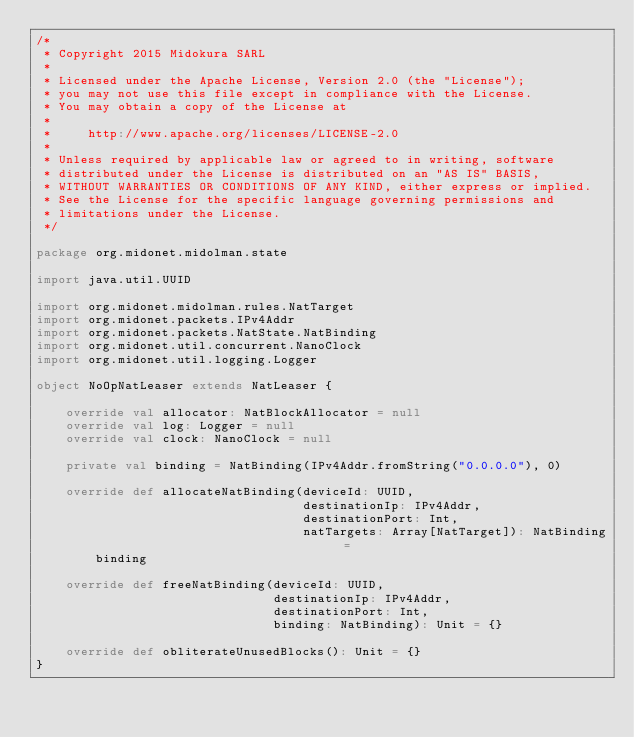<code> <loc_0><loc_0><loc_500><loc_500><_Scala_>/*
 * Copyright 2015 Midokura SARL
 *
 * Licensed under the Apache License, Version 2.0 (the "License");
 * you may not use this file except in compliance with the License.
 * You may obtain a copy of the License at
 *
 *     http://www.apache.org/licenses/LICENSE-2.0
 *
 * Unless required by applicable law or agreed to in writing, software
 * distributed under the License is distributed on an "AS IS" BASIS,
 * WITHOUT WARRANTIES OR CONDITIONS OF ANY KIND, either express or implied.
 * See the License for the specific language governing permissions and
 * limitations under the License.
 */

package org.midonet.midolman.state

import java.util.UUID

import org.midonet.midolman.rules.NatTarget
import org.midonet.packets.IPv4Addr
import org.midonet.packets.NatState.NatBinding
import org.midonet.util.concurrent.NanoClock
import org.midonet.util.logging.Logger

object NoOpNatLeaser extends NatLeaser {

    override val allocator: NatBlockAllocator = null
    override val log: Logger = null
    override val clock: NanoClock = null

    private val binding = NatBinding(IPv4Addr.fromString("0.0.0.0"), 0)

    override def allocateNatBinding(deviceId: UUID,
                                    destinationIp: IPv4Addr,
                                    destinationPort: Int,
                                    natTargets: Array[NatTarget]): NatBinding =
        binding

    override def freeNatBinding(deviceId: UUID,
                                destinationIp: IPv4Addr,
                                destinationPort: Int,
                                binding: NatBinding): Unit = {}

    override def obliterateUnusedBlocks(): Unit = {}
}
</code> 